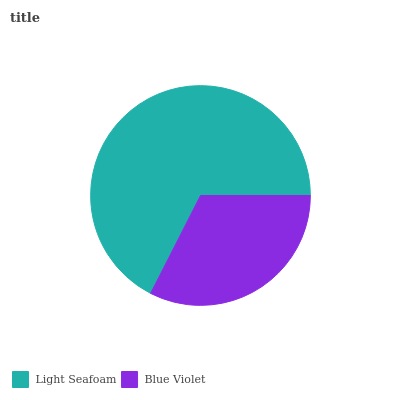Is Blue Violet the minimum?
Answer yes or no. Yes. Is Light Seafoam the maximum?
Answer yes or no. Yes. Is Blue Violet the maximum?
Answer yes or no. No. Is Light Seafoam greater than Blue Violet?
Answer yes or no. Yes. Is Blue Violet less than Light Seafoam?
Answer yes or no. Yes. Is Blue Violet greater than Light Seafoam?
Answer yes or no. No. Is Light Seafoam less than Blue Violet?
Answer yes or no. No. Is Light Seafoam the high median?
Answer yes or no. Yes. Is Blue Violet the low median?
Answer yes or no. Yes. Is Blue Violet the high median?
Answer yes or no. No. Is Light Seafoam the low median?
Answer yes or no. No. 